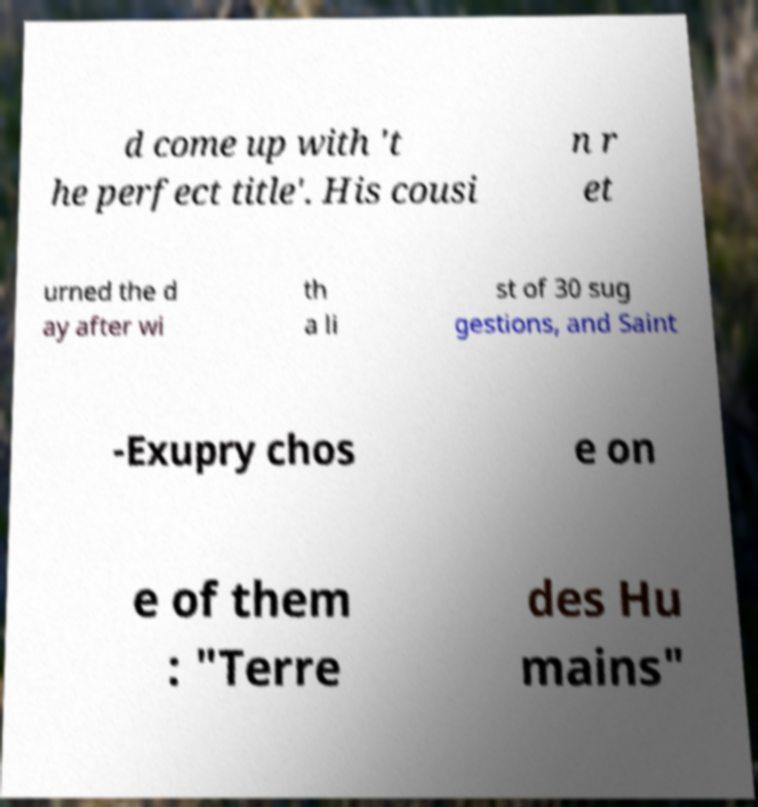Could you extract and type out the text from this image? d come up with 't he perfect title'. His cousi n r et urned the d ay after wi th a li st of 30 sug gestions, and Saint -Exupry chos e on e of them : "Terre des Hu mains" 